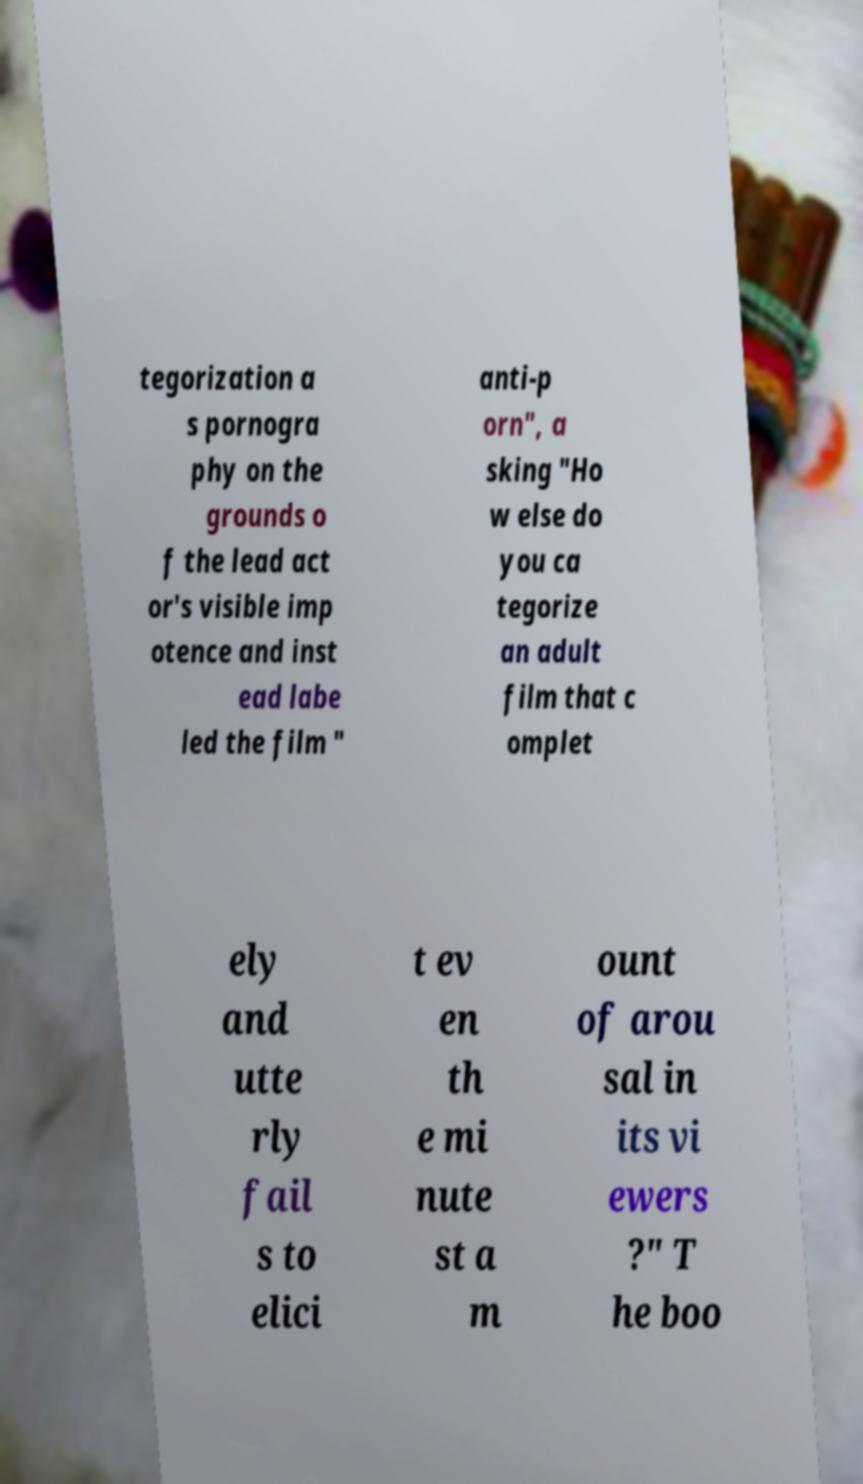Can you read and provide the text displayed in the image?This photo seems to have some interesting text. Can you extract and type it out for me? tegorization a s pornogra phy on the grounds o f the lead act or's visible imp otence and inst ead labe led the film " anti-p orn", a sking "Ho w else do you ca tegorize an adult film that c omplet ely and utte rly fail s to elici t ev en th e mi nute st a m ount of arou sal in its vi ewers ?" T he boo 